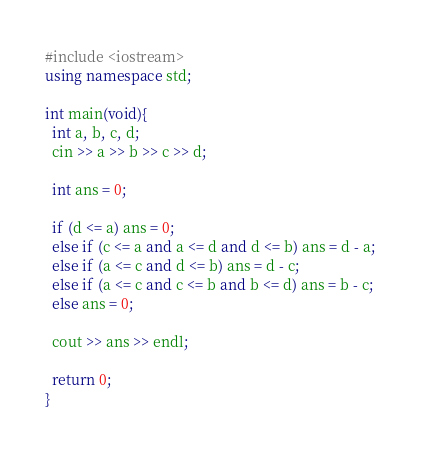<code> <loc_0><loc_0><loc_500><loc_500><_C++_>#include <iostream>
using namespace std;

int main(void){
  int a, b, c, d;
  cin >> a >> b >> c >> d;
  
  int ans = 0;
  
  if (d <= a) ans = 0;
  else if (c <= a and a <= d and d <= b) ans = d - a;
  else if (a <= c and d <= b) ans = d - c;
  else if (a <= c and c <= b and b <= d) ans = b - c;
  else ans = 0;
  
  cout >> ans >> endl;
  
  return 0;
}</code> 